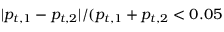<formula> <loc_0><loc_0><loc_500><loc_500>| p _ { t , 1 } - p _ { t , 2 } | / ( p _ { t , 1 } + p _ { t , 2 } < 0 . 0 5</formula> 